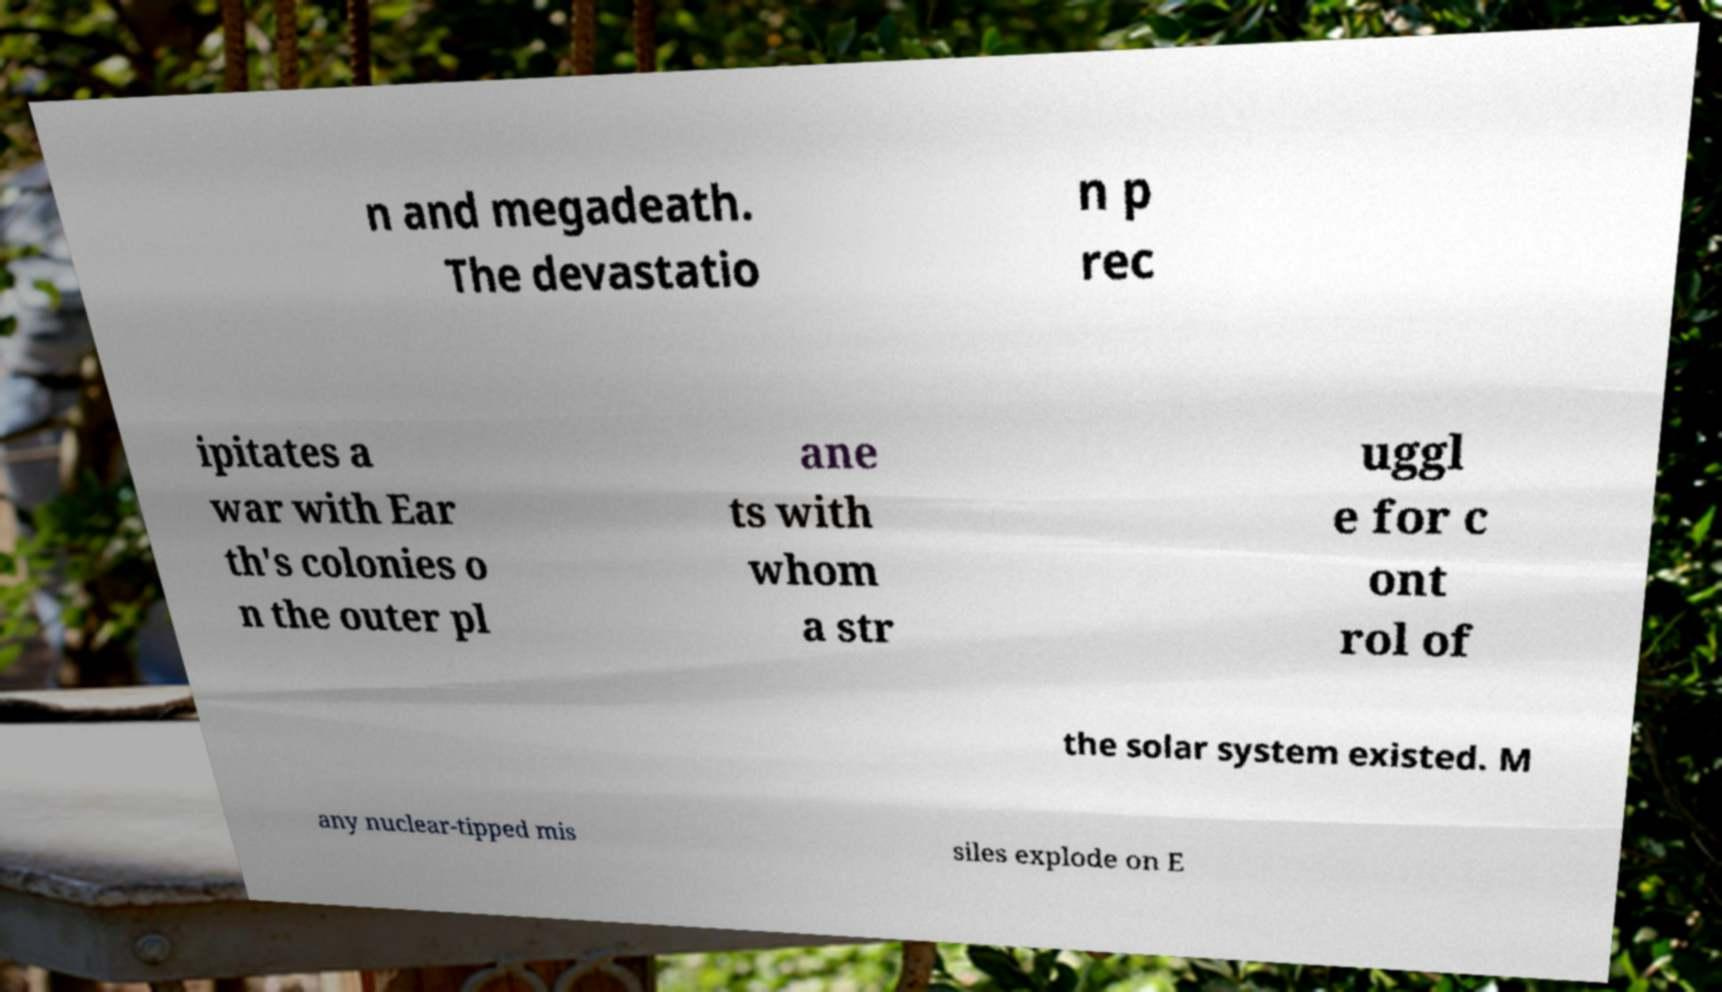Can you read and provide the text displayed in the image?This photo seems to have some interesting text. Can you extract and type it out for me? n and megadeath. The devastatio n p rec ipitates a war with Ear th's colonies o n the outer pl ane ts with whom a str uggl e for c ont rol of the solar system existed. M any nuclear-tipped mis siles explode on E 